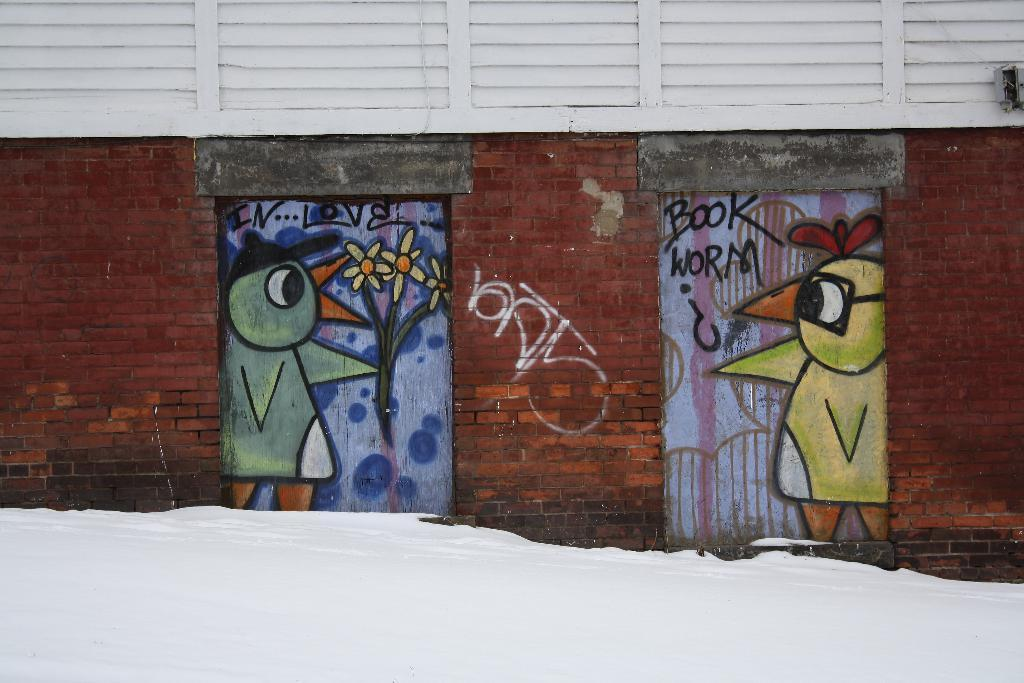What is depicted on the doors in the image? The doors have paintings on them. What else can be seen in the image besides the doors? There is a wall visible in the image. Can you see a tiger walking on the wall in the image? No, there is no tiger or any other animal visible on the wall in the image. 